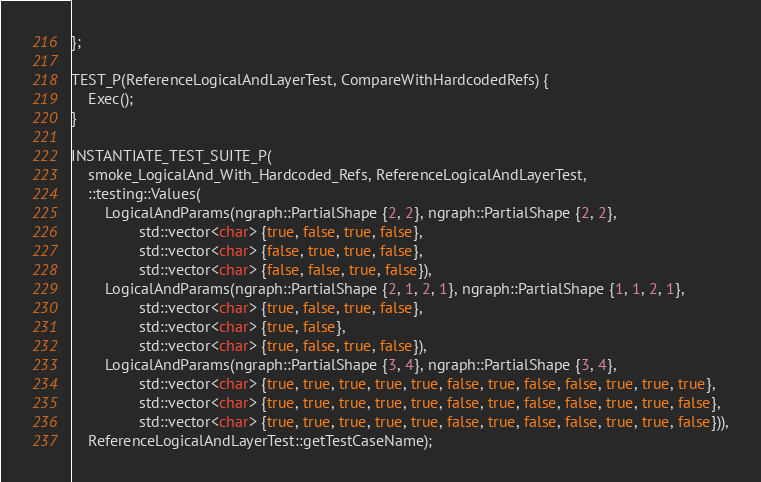Convert code to text. <code><loc_0><loc_0><loc_500><loc_500><_C++_>};

TEST_P(ReferenceLogicalAndLayerTest, CompareWithHardcodedRefs) {
    Exec();
}

INSTANTIATE_TEST_SUITE_P(
    smoke_LogicalAnd_With_Hardcoded_Refs, ReferenceLogicalAndLayerTest,
    ::testing::Values(
        LogicalAndParams(ngraph::PartialShape {2, 2}, ngraph::PartialShape {2, 2},
                std::vector<char> {true, false, true, false},
                std::vector<char> {false, true, true, false},
                std::vector<char> {false, false, true, false}),
        LogicalAndParams(ngraph::PartialShape {2, 1, 2, 1}, ngraph::PartialShape {1, 1, 2, 1},
                std::vector<char> {true, false, true, false},
                std::vector<char> {true, false},
                std::vector<char> {true, false, true, false}),
        LogicalAndParams(ngraph::PartialShape {3, 4}, ngraph::PartialShape {3, 4},
                std::vector<char> {true, true, true, true, true, false, true, false, false, true, true, true},
                std::vector<char> {true, true, true, true, true, false, true, false, false, true, true, false},
                std::vector<char> {true, true, true, true, true, false, true, false, false, true, true, false})),
    ReferenceLogicalAndLayerTest::getTestCaseName);
</code> 